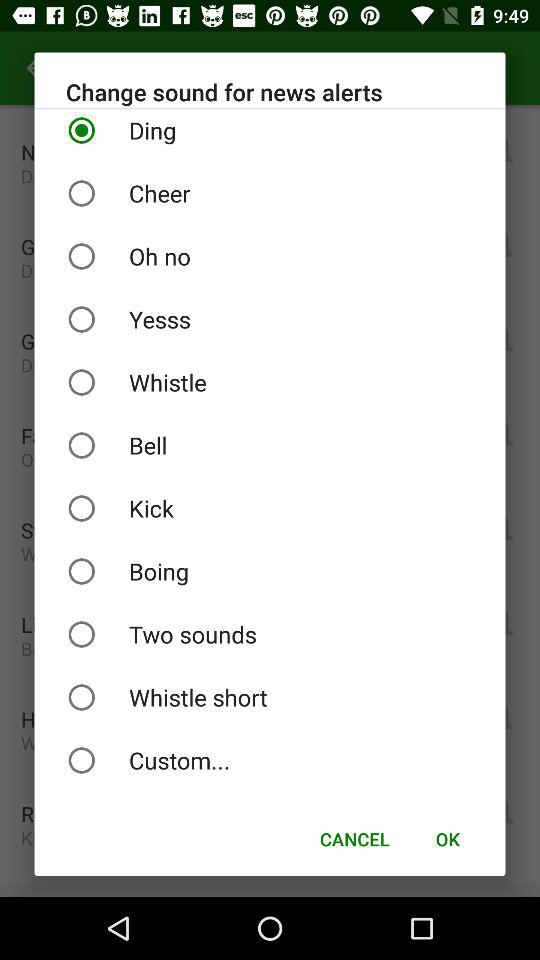What's the selected sound for news alerts? The selected sound is "Ding". 